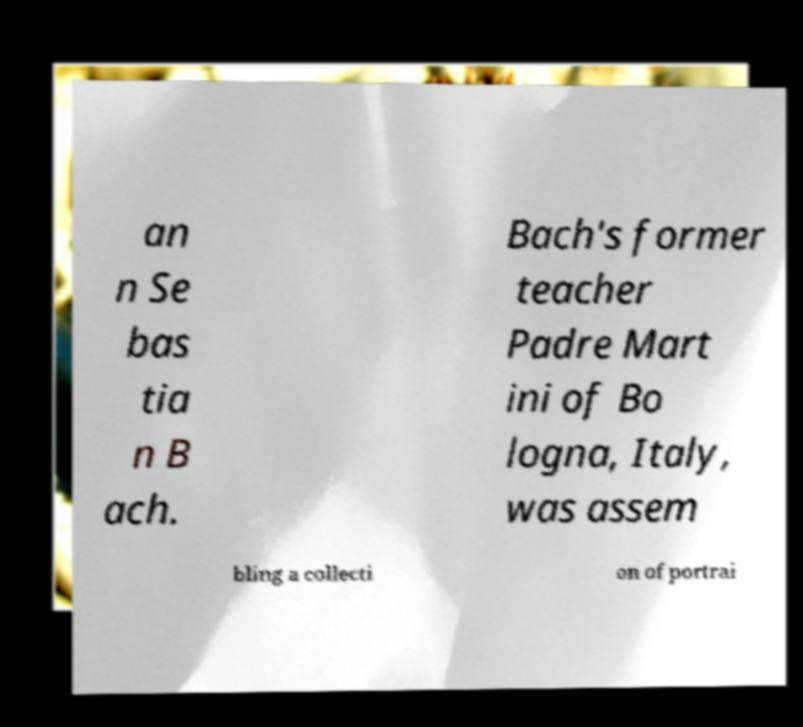Can you read and provide the text displayed in the image?This photo seems to have some interesting text. Can you extract and type it out for me? an n Se bas tia n B ach. Bach's former teacher Padre Mart ini of Bo logna, Italy, was assem bling a collecti on of portrai 